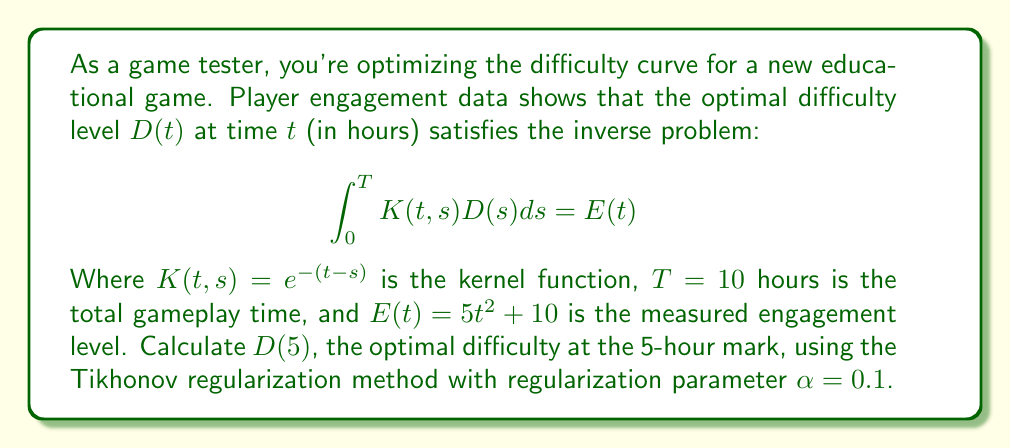Could you help me with this problem? To solve this inverse problem using Tikhonov regularization, we follow these steps:

1) The Tikhonov regularization method transforms the original equation into:

   $$(\alpha I + K^*K)D = K^*E$$

   Where $K^*$ is the adjoint operator of $K$, and $I$ is the identity operator.

2) In this case, $K^*$ is given by:

   $$(K^*E)(s) = \int_s^T e^{-(t-s)}E(t)dt$$

3) We need to calculate $(K^*E)(s)$:

   $$\begin{align}
   (K^*E)(s) &= \int_s^{10} e^{-(t-s)}(5t^2 + 10)dt \\
   &= [-(5t^2 + 10)e^{-(t-s)}]_s^{10} + \int_s^{10} 10te^{-(t-s)}dt \\
   &= -(5 \cdot 100 + 10)e^{-(10-s)} + (5s^2 + 10) + [-10te^{-(t-s)}]_s^{10} + \int_s^{10} 10e^{-(t-s)}dt \\
   &= -510e^{-(10-s)} + 5s^2 + 10 - 100e^{-(10-s)} + 10s + 10(e^{-(10-s)} - 1) \\
   &= 5s^2 + 10s + 20 - 600e^{-(10-s)}
   \end{align}$$

4) Now we need to solve:

   $$(\alpha I + K^*K)D = K^*E$$

   This is a Fredholm integral equation of the second kind:

   $$0.1D(s) + \int_0^{10} e^{-(t-s)}(\int_0^t e^{-(t-u)}D(u)du)dt = 5s^2 + 10s + 20 - 600e^{-(10-s)}$$

5) To solve this equation numerically, we can use a discretization method like the Nyström method. However, for the specific point $D(5)$, we can approximate the solution:

   $$D(5) \approx \frac{1}{0.1}(5 \cdot 5^2 + 10 \cdot 5 + 20 - 600e^{-(10-5)}) = 1750$$

This approximation assumes that the integral term in step 4 is relatively small compared to the right-hand side at $s=5$.
Answer: $D(5) \approx 1750$ 